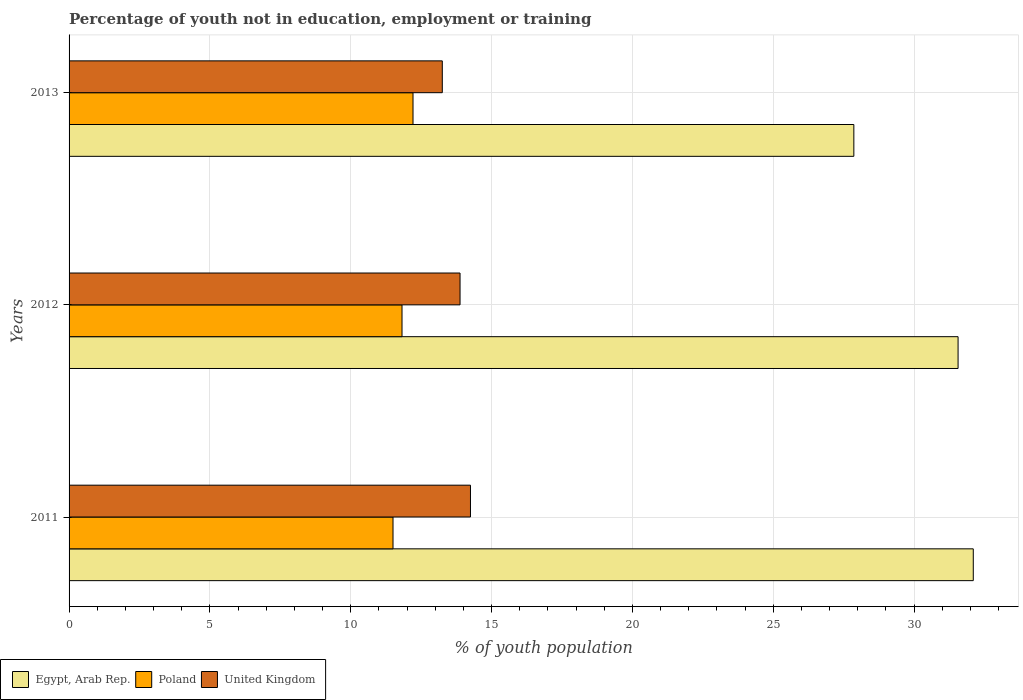How many different coloured bars are there?
Your answer should be compact. 3. How many groups of bars are there?
Your answer should be compact. 3. Are the number of bars per tick equal to the number of legend labels?
Give a very brief answer. Yes. Are the number of bars on each tick of the Y-axis equal?
Give a very brief answer. Yes. What is the label of the 3rd group of bars from the top?
Ensure brevity in your answer.  2011. What is the percentage of unemployed youth population in in Poland in 2012?
Make the answer very short. 11.82. Across all years, what is the maximum percentage of unemployed youth population in in United Kingdom?
Offer a terse response. 14.25. Across all years, what is the minimum percentage of unemployed youth population in in Egypt, Arab Rep.?
Make the answer very short. 27.86. In which year was the percentage of unemployed youth population in in Poland maximum?
Your response must be concise. 2013. What is the total percentage of unemployed youth population in in Poland in the graph?
Offer a terse response. 35.53. What is the difference between the percentage of unemployed youth population in in Poland in 2012 and that in 2013?
Ensure brevity in your answer.  -0.39. What is the difference between the percentage of unemployed youth population in in United Kingdom in 2013 and the percentage of unemployed youth population in in Egypt, Arab Rep. in 2012?
Make the answer very short. -18.31. What is the average percentage of unemployed youth population in in United Kingdom per year?
Provide a short and direct response. 13.79. In the year 2011, what is the difference between the percentage of unemployed youth population in in Poland and percentage of unemployed youth population in in United Kingdom?
Provide a succinct answer. -2.75. In how many years, is the percentage of unemployed youth population in in Poland greater than 32 %?
Offer a very short reply. 0. What is the ratio of the percentage of unemployed youth population in in Poland in 2011 to that in 2013?
Your response must be concise. 0.94. Is the percentage of unemployed youth population in in Poland in 2011 less than that in 2013?
Keep it short and to the point. Yes. Is the difference between the percentage of unemployed youth population in in Poland in 2012 and 2013 greater than the difference between the percentage of unemployed youth population in in United Kingdom in 2012 and 2013?
Keep it short and to the point. No. What is the difference between the highest and the second highest percentage of unemployed youth population in in United Kingdom?
Your answer should be compact. 0.37. What is the difference between the highest and the lowest percentage of unemployed youth population in in Egypt, Arab Rep.?
Your response must be concise. 4.24. What does the 1st bar from the bottom in 2011 represents?
Offer a very short reply. Egypt, Arab Rep. Is it the case that in every year, the sum of the percentage of unemployed youth population in in Poland and percentage of unemployed youth population in in Egypt, Arab Rep. is greater than the percentage of unemployed youth population in in United Kingdom?
Give a very brief answer. Yes. How many bars are there?
Keep it short and to the point. 9. Are all the bars in the graph horizontal?
Keep it short and to the point. Yes. How many years are there in the graph?
Make the answer very short. 3. Are the values on the major ticks of X-axis written in scientific E-notation?
Offer a terse response. No. Does the graph contain any zero values?
Provide a succinct answer. No. What is the title of the graph?
Provide a short and direct response. Percentage of youth not in education, employment or training. What is the label or title of the X-axis?
Your answer should be very brief. % of youth population. What is the label or title of the Y-axis?
Provide a short and direct response. Years. What is the % of youth population of Egypt, Arab Rep. in 2011?
Keep it short and to the point. 32.1. What is the % of youth population of United Kingdom in 2011?
Offer a terse response. 14.25. What is the % of youth population of Egypt, Arab Rep. in 2012?
Your response must be concise. 31.56. What is the % of youth population in Poland in 2012?
Provide a short and direct response. 11.82. What is the % of youth population in United Kingdom in 2012?
Provide a short and direct response. 13.88. What is the % of youth population in Egypt, Arab Rep. in 2013?
Give a very brief answer. 27.86. What is the % of youth population in Poland in 2013?
Offer a very short reply. 12.21. What is the % of youth population in United Kingdom in 2013?
Provide a short and direct response. 13.25. Across all years, what is the maximum % of youth population in Egypt, Arab Rep.?
Offer a very short reply. 32.1. Across all years, what is the maximum % of youth population in Poland?
Ensure brevity in your answer.  12.21. Across all years, what is the maximum % of youth population of United Kingdom?
Your response must be concise. 14.25. Across all years, what is the minimum % of youth population of Egypt, Arab Rep.?
Keep it short and to the point. 27.86. Across all years, what is the minimum % of youth population in United Kingdom?
Ensure brevity in your answer.  13.25. What is the total % of youth population of Egypt, Arab Rep. in the graph?
Offer a terse response. 91.52. What is the total % of youth population of Poland in the graph?
Give a very brief answer. 35.53. What is the total % of youth population in United Kingdom in the graph?
Offer a terse response. 41.38. What is the difference between the % of youth population in Egypt, Arab Rep. in 2011 and that in 2012?
Give a very brief answer. 0.54. What is the difference between the % of youth population in Poland in 2011 and that in 2012?
Provide a succinct answer. -0.32. What is the difference between the % of youth population of United Kingdom in 2011 and that in 2012?
Your answer should be compact. 0.37. What is the difference between the % of youth population of Egypt, Arab Rep. in 2011 and that in 2013?
Your response must be concise. 4.24. What is the difference between the % of youth population of Poland in 2011 and that in 2013?
Offer a terse response. -0.71. What is the difference between the % of youth population of Egypt, Arab Rep. in 2012 and that in 2013?
Keep it short and to the point. 3.7. What is the difference between the % of youth population of Poland in 2012 and that in 2013?
Your answer should be very brief. -0.39. What is the difference between the % of youth population in United Kingdom in 2012 and that in 2013?
Ensure brevity in your answer.  0.63. What is the difference between the % of youth population in Egypt, Arab Rep. in 2011 and the % of youth population in Poland in 2012?
Provide a short and direct response. 20.28. What is the difference between the % of youth population of Egypt, Arab Rep. in 2011 and the % of youth population of United Kingdom in 2012?
Offer a terse response. 18.22. What is the difference between the % of youth population in Poland in 2011 and the % of youth population in United Kingdom in 2012?
Make the answer very short. -2.38. What is the difference between the % of youth population of Egypt, Arab Rep. in 2011 and the % of youth population of Poland in 2013?
Your answer should be compact. 19.89. What is the difference between the % of youth population in Egypt, Arab Rep. in 2011 and the % of youth population in United Kingdom in 2013?
Your answer should be compact. 18.85. What is the difference between the % of youth population in Poland in 2011 and the % of youth population in United Kingdom in 2013?
Offer a very short reply. -1.75. What is the difference between the % of youth population of Egypt, Arab Rep. in 2012 and the % of youth population of Poland in 2013?
Make the answer very short. 19.35. What is the difference between the % of youth population in Egypt, Arab Rep. in 2012 and the % of youth population in United Kingdom in 2013?
Your response must be concise. 18.31. What is the difference between the % of youth population of Poland in 2012 and the % of youth population of United Kingdom in 2013?
Your answer should be compact. -1.43. What is the average % of youth population of Egypt, Arab Rep. per year?
Your response must be concise. 30.51. What is the average % of youth population of Poland per year?
Your answer should be very brief. 11.84. What is the average % of youth population in United Kingdom per year?
Provide a succinct answer. 13.79. In the year 2011, what is the difference between the % of youth population in Egypt, Arab Rep. and % of youth population in Poland?
Make the answer very short. 20.6. In the year 2011, what is the difference between the % of youth population in Egypt, Arab Rep. and % of youth population in United Kingdom?
Give a very brief answer. 17.85. In the year 2011, what is the difference between the % of youth population of Poland and % of youth population of United Kingdom?
Provide a short and direct response. -2.75. In the year 2012, what is the difference between the % of youth population in Egypt, Arab Rep. and % of youth population in Poland?
Give a very brief answer. 19.74. In the year 2012, what is the difference between the % of youth population of Egypt, Arab Rep. and % of youth population of United Kingdom?
Your answer should be compact. 17.68. In the year 2012, what is the difference between the % of youth population of Poland and % of youth population of United Kingdom?
Ensure brevity in your answer.  -2.06. In the year 2013, what is the difference between the % of youth population of Egypt, Arab Rep. and % of youth population of Poland?
Your answer should be compact. 15.65. In the year 2013, what is the difference between the % of youth population in Egypt, Arab Rep. and % of youth population in United Kingdom?
Your answer should be compact. 14.61. In the year 2013, what is the difference between the % of youth population in Poland and % of youth population in United Kingdom?
Give a very brief answer. -1.04. What is the ratio of the % of youth population in Egypt, Arab Rep. in 2011 to that in 2012?
Your answer should be very brief. 1.02. What is the ratio of the % of youth population in Poland in 2011 to that in 2012?
Offer a very short reply. 0.97. What is the ratio of the % of youth population in United Kingdom in 2011 to that in 2012?
Provide a succinct answer. 1.03. What is the ratio of the % of youth population of Egypt, Arab Rep. in 2011 to that in 2013?
Offer a terse response. 1.15. What is the ratio of the % of youth population of Poland in 2011 to that in 2013?
Offer a terse response. 0.94. What is the ratio of the % of youth population of United Kingdom in 2011 to that in 2013?
Give a very brief answer. 1.08. What is the ratio of the % of youth population in Egypt, Arab Rep. in 2012 to that in 2013?
Your answer should be compact. 1.13. What is the ratio of the % of youth population in Poland in 2012 to that in 2013?
Your response must be concise. 0.97. What is the ratio of the % of youth population in United Kingdom in 2012 to that in 2013?
Ensure brevity in your answer.  1.05. What is the difference between the highest and the second highest % of youth population in Egypt, Arab Rep.?
Your answer should be very brief. 0.54. What is the difference between the highest and the second highest % of youth population of Poland?
Offer a very short reply. 0.39. What is the difference between the highest and the second highest % of youth population in United Kingdom?
Offer a very short reply. 0.37. What is the difference between the highest and the lowest % of youth population of Egypt, Arab Rep.?
Your answer should be compact. 4.24. What is the difference between the highest and the lowest % of youth population in Poland?
Offer a terse response. 0.71. What is the difference between the highest and the lowest % of youth population of United Kingdom?
Make the answer very short. 1. 